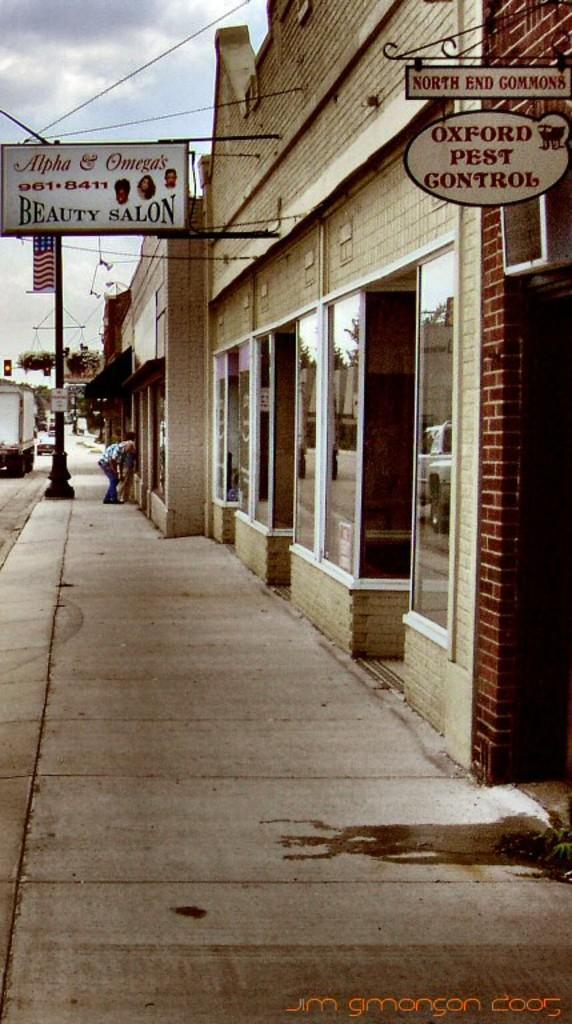Please provide a concise description of this image. In the picture I can see the buildings on the right side. I can see the hoarding board, a flagpole on the left side. I can see two persons on the side of the road. There are vehicles on the road. There are clouds in the sky. 